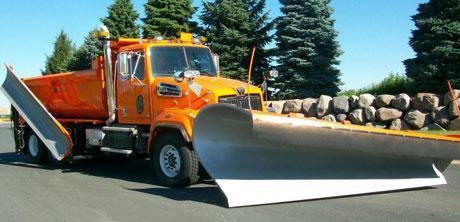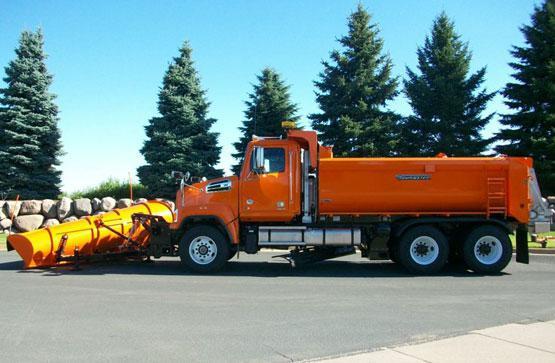The first image is the image on the left, the second image is the image on the right. For the images shown, is this caption "The truck is passing a building in one of the iamges." true? Answer yes or no. No. 